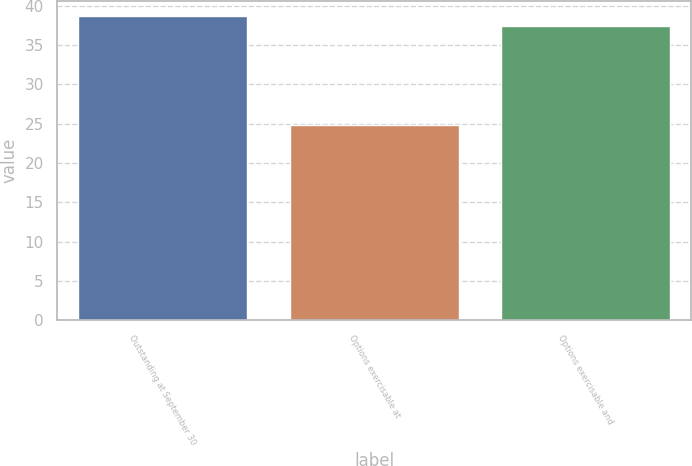Convert chart to OTSL. <chart><loc_0><loc_0><loc_500><loc_500><bar_chart><fcel>Outstanding at September 30<fcel>Options exercisable at<fcel>Options exercisable and<nl><fcel>38.7<fcel>24.87<fcel>37.35<nl></chart> 